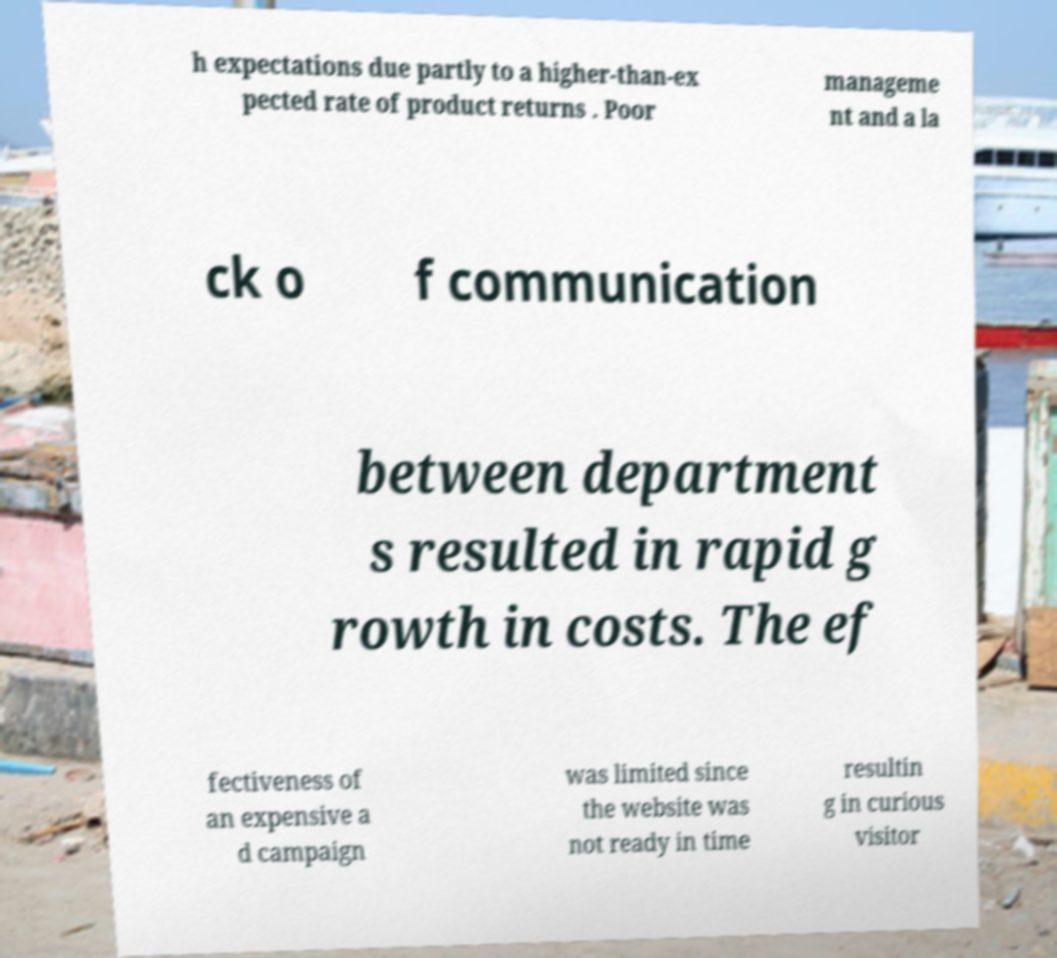Could you extract and type out the text from this image? h expectations due partly to a higher-than-ex pected rate of product returns . Poor manageme nt and a la ck o f communication between department s resulted in rapid g rowth in costs. The ef fectiveness of an expensive a d campaign was limited since the website was not ready in time resultin g in curious visitor 